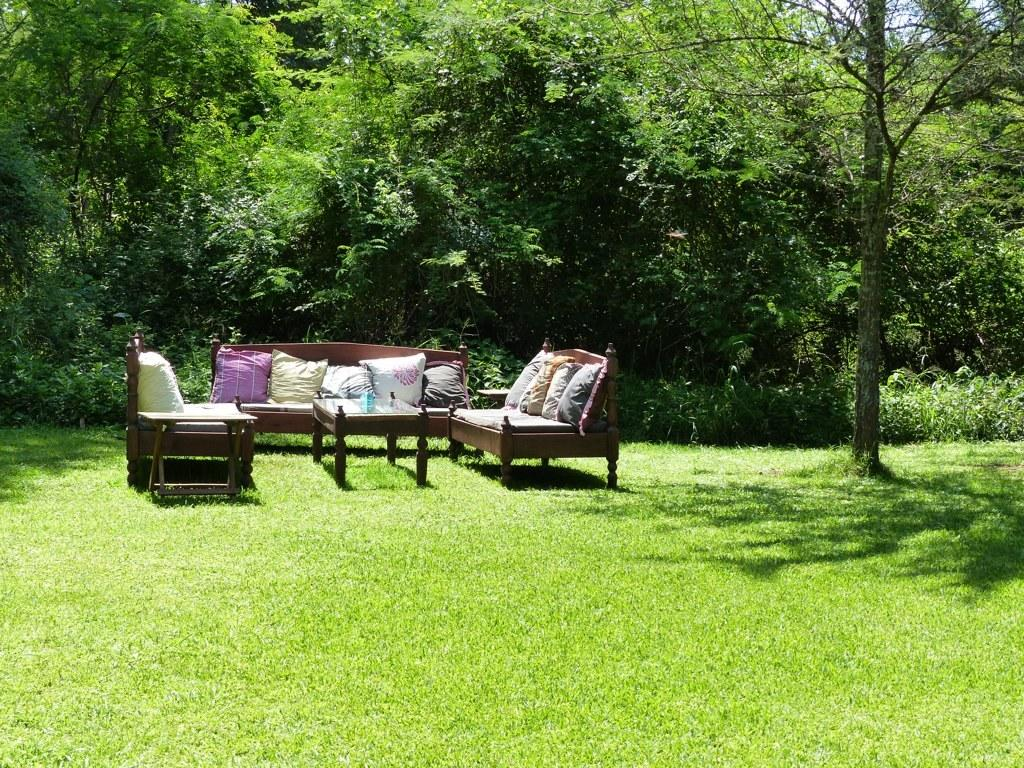What type of furniture is present in the image? There is a sofa set and a table in the image. Where are the sofa set and table located? The sofa set and table are placed in a garden. What can be seen in the background of the image? There is a tree and multiple trees in the background of the image, as well as plants. What word is written on the sofa in the image? There is no word written on the sofa in the image. 